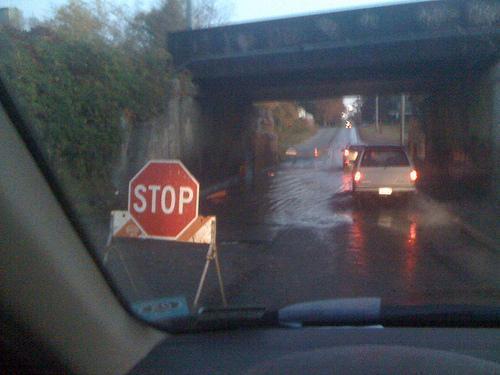How many stop signs are there?
Give a very brief answer. 1. 